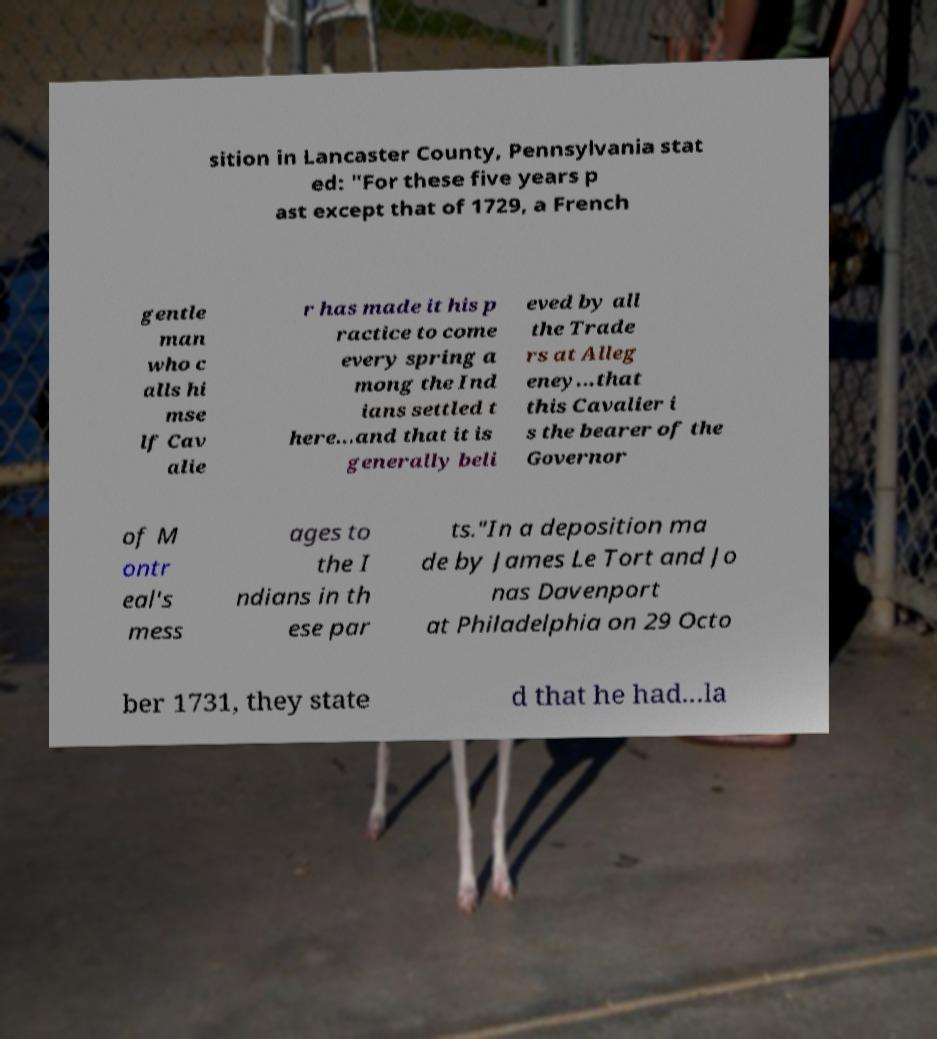Could you assist in decoding the text presented in this image and type it out clearly? sition in Lancaster County, Pennsylvania stat ed: "For these five years p ast except that of 1729, a French gentle man who c alls hi mse lf Cav alie r has made it his p ractice to come every spring a mong the Ind ians settled t here...and that it is generally beli eved by all the Trade rs at Alleg eney...that this Cavalier i s the bearer of the Governor of M ontr eal's mess ages to the I ndians in th ese par ts."In a deposition ma de by James Le Tort and Jo nas Davenport at Philadelphia on 29 Octo ber 1731, they state d that he had...la 